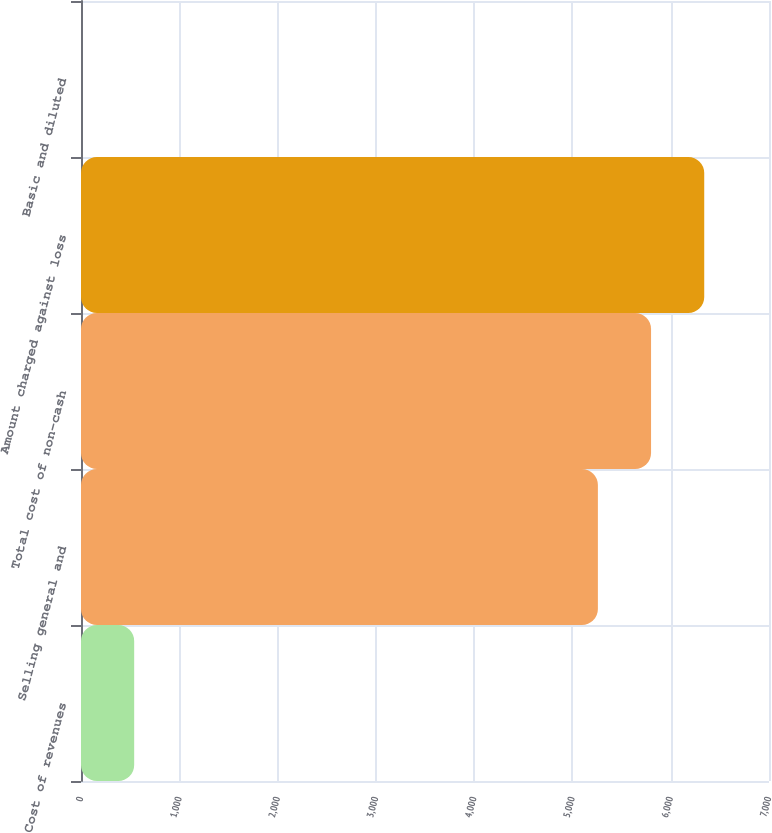Convert chart. <chart><loc_0><loc_0><loc_500><loc_500><bar_chart><fcel>Cost of revenues<fcel>Selling general and<fcel>Total cost of non-cash<fcel>Amount charged against loss<fcel>Basic and diluted<nl><fcel>541.05<fcel>5259<fcel>5799.99<fcel>6340.98<fcel>0.06<nl></chart> 